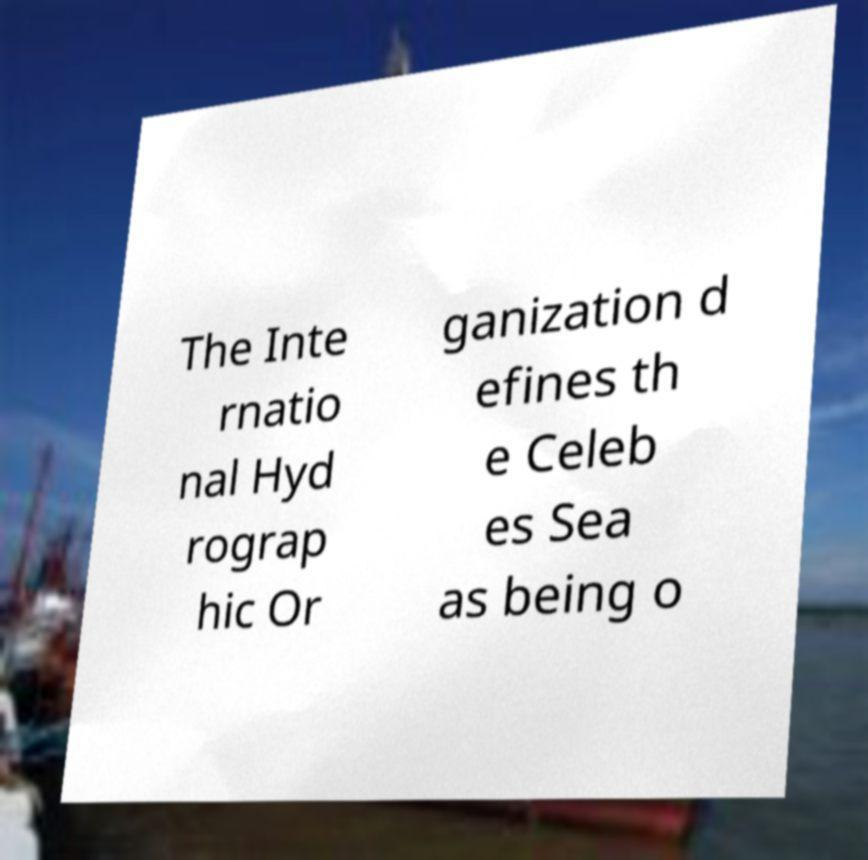There's text embedded in this image that I need extracted. Can you transcribe it verbatim? The Inte rnatio nal Hyd rograp hic Or ganization d efines th e Celeb es Sea as being o 